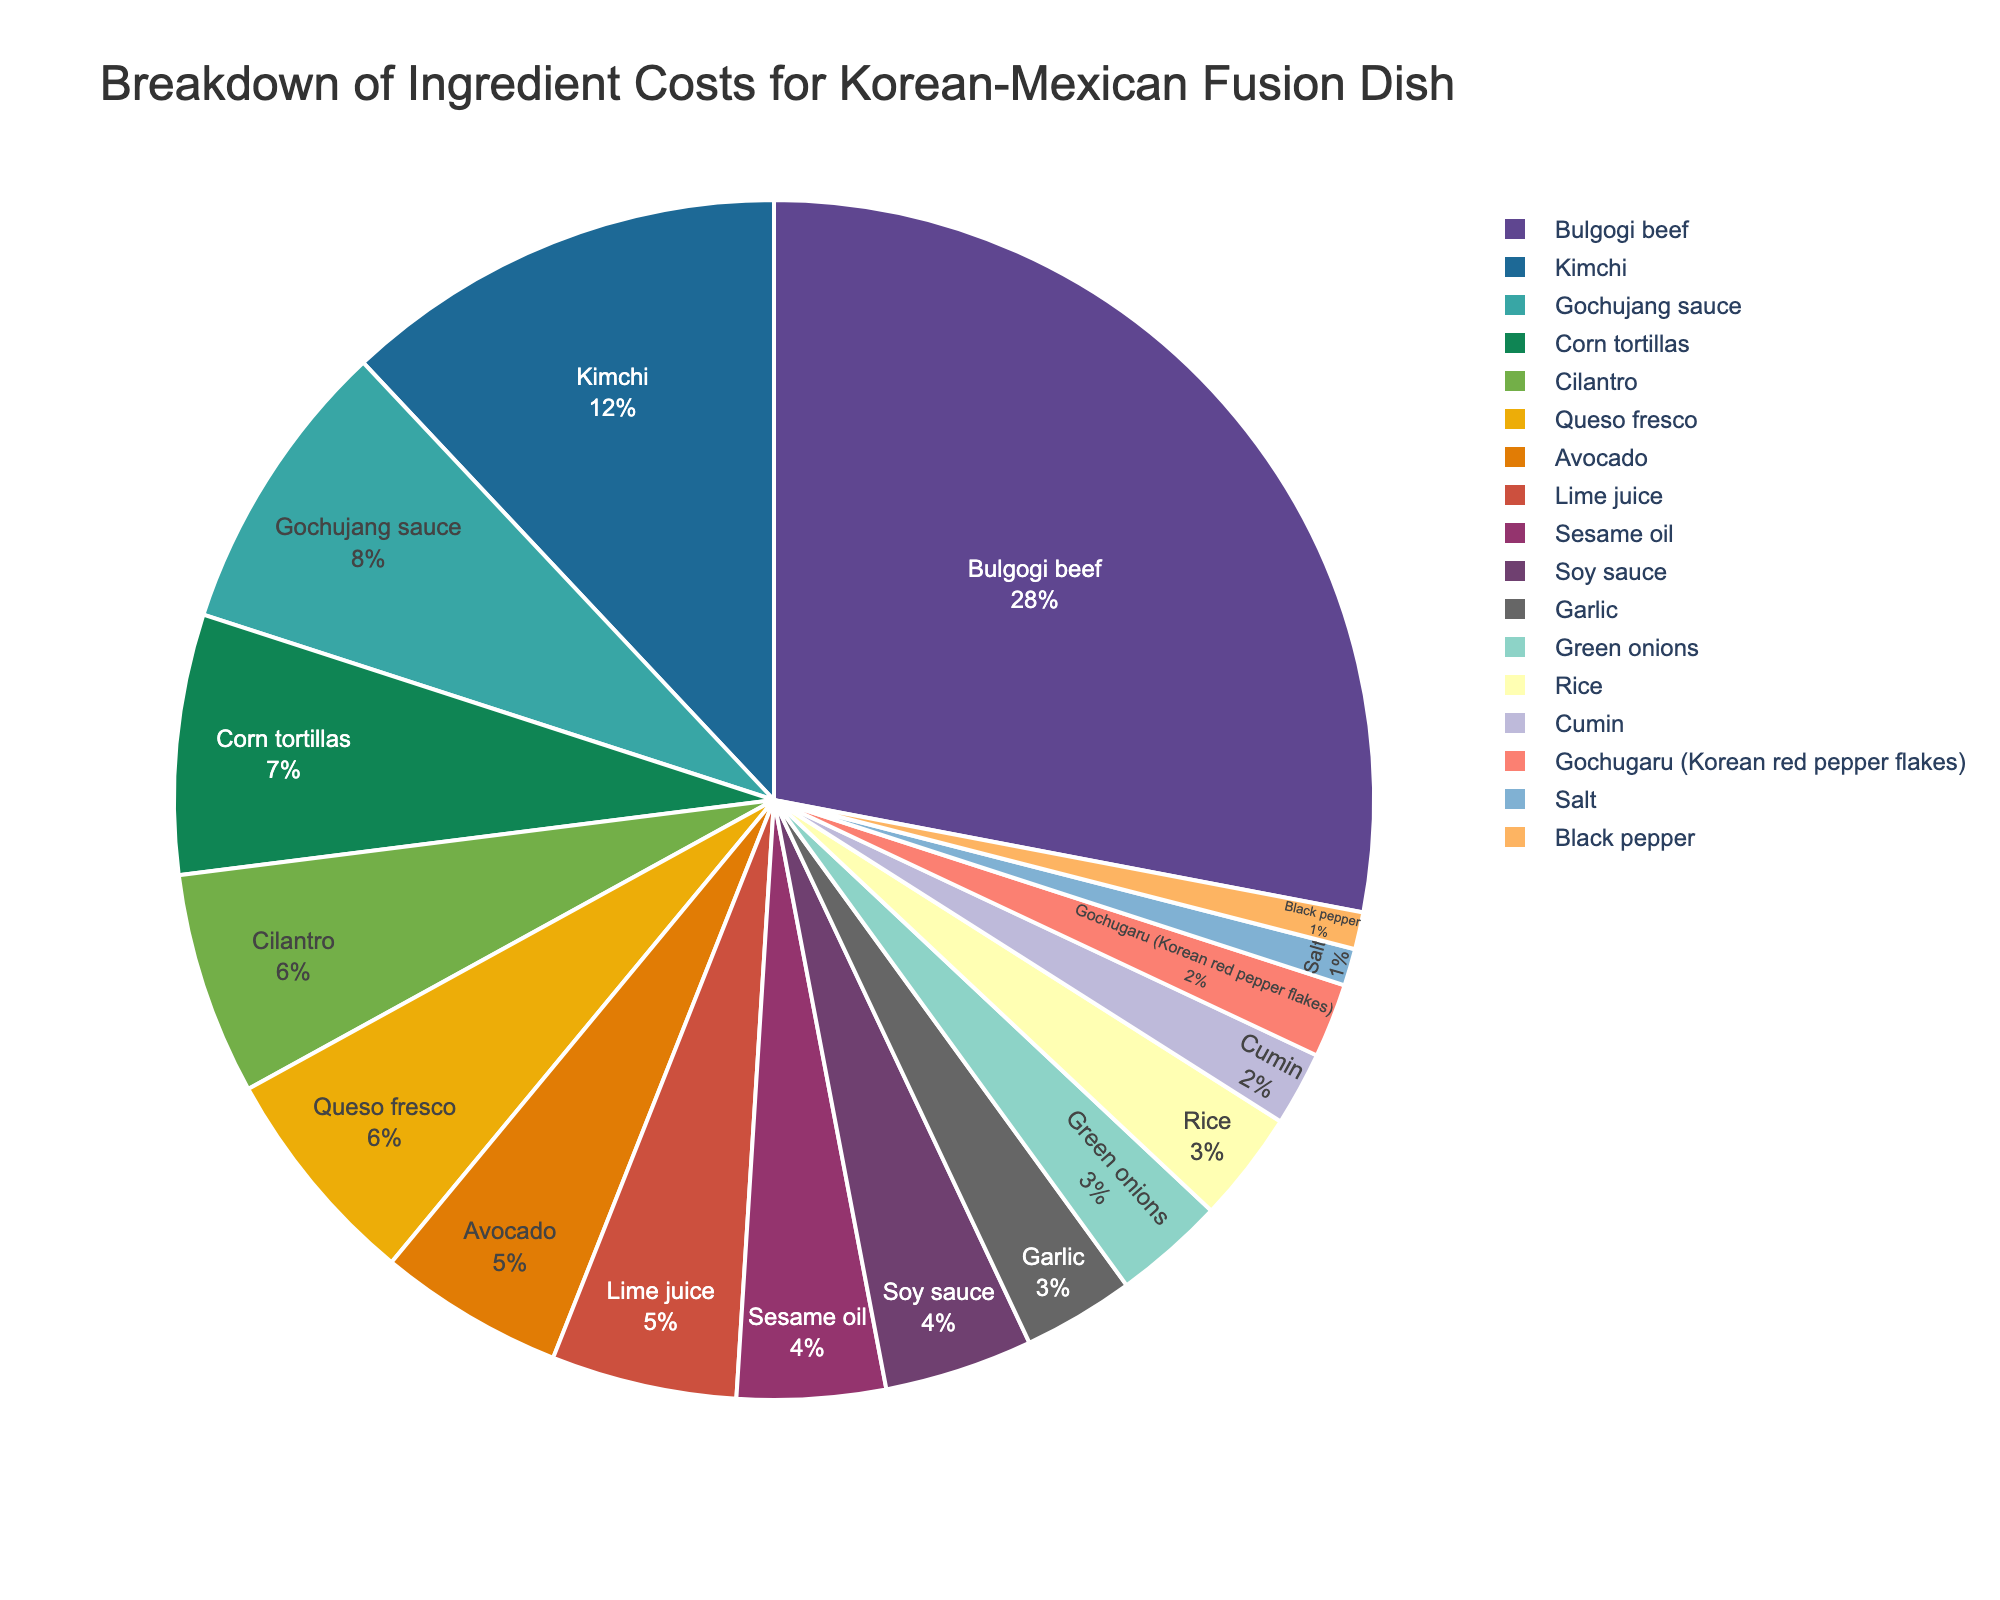What's the cost percentage for the ingredient with the lowest cost? The ingredient with the lowest cost is "Salt" and its cost percentage is displayed as 1% in the pie chart.
Answer: 1% Which ingredient has the highest cost percentage? The largest segment in the pie chart corresponds to "Bulgogi beef", indicating it's the ingredient with the highest cost percentage at 28%.
Answer: Bulgogi beef How much greater is the cost percentage of Bulgogi beef compared to Kimchi? Bulgogi beef has a cost percentage of 28%, and Kimchi has a cost percentage of 12%. The difference is calculated as 28% - 12% = 16%.
Answer: 16% What is the combined cost percentage of Garlic, Green onions, and Rice? Adding the cost percentages for Garlic (3%), Green onions (3%), and Rice (3%) gives a total of 3% + 3% + 3% = 9%.
Answer: 9% Is the cost percentage for Gochujang sauce greater than or equal to Corn tortillas? The cost percentage for Gochujang sauce is 8% while for Corn tortillas it is 7%. Since 8% is greater than 7%, the answer is yes.
Answer: Yes Which ingredients have an equal cost percentage? The ingredients "Cilantro" and "Queso fresco" both have a cost percentage of 6%. The same applies to "Sesame oil" and "Soy sauce" with 4%, and to "Garlic," "Green onions," and "Rice," each with 3%.
Answer: Cilantro and Queso fresco; Sesame oil and Soy sauce; Garlic, Green onions, and Rice What is the total cost percentage of all the ingredients listed? Adding up all the individual cost percentages: 28% + 12% + 8% + 7% + 6% + 6% + 5% + 5% + 4% + 4% + 3% + 3% + 3% + 2% + 2% + 1% + 1% = 100%.
Answer: 100% What is the ratio of the cost percentage of Avocado to Gochugaru (Korean red pepper flakes)? The cost percentage for Avocado is 5%, and for Gochugaru it is 2%. The ratio is calculated as 5% / 2% = 2.5.
Answer: 2.5 If you combine the cost percentages of Gochujang sauce, Corn tortillas, and Cumin, what portion of the total cost percentage do they represent? Adding the cost percentages of Gochujang sauce (8%), Corn tortillas (7%), and Cumin (2%) gives 8% + 7% + 2% = 17%. Out of a total of 100%, this represents 17%.
Answer: 17% 